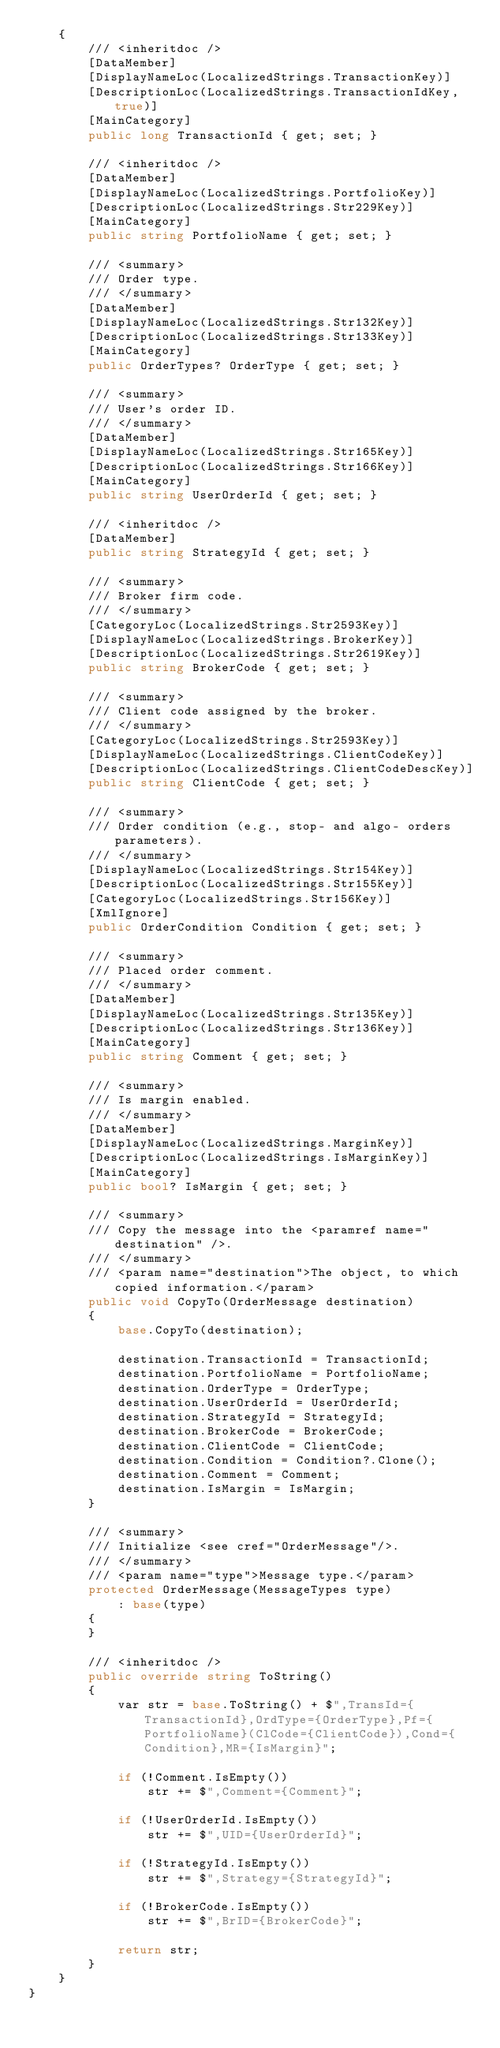<code> <loc_0><loc_0><loc_500><loc_500><_C#_>	{
		/// <inheritdoc />
		[DataMember]
		[DisplayNameLoc(LocalizedStrings.TransactionKey)]
		[DescriptionLoc(LocalizedStrings.TransactionIdKey, true)]
		[MainCategory]
		public long TransactionId { get; set; }

		/// <inheritdoc />
		[DataMember]
		[DisplayNameLoc(LocalizedStrings.PortfolioKey)]
		[DescriptionLoc(LocalizedStrings.Str229Key)]
		[MainCategory]
		public string PortfolioName { get; set; }

		/// <summary>
		/// Order type.
		/// </summary>
		[DataMember]
		[DisplayNameLoc(LocalizedStrings.Str132Key)]
		[DescriptionLoc(LocalizedStrings.Str133Key)]
		[MainCategory]
		public OrderTypes? OrderType { get; set; }

		/// <summary>
		/// User's order ID.
		/// </summary>
		[DataMember]
		[DisplayNameLoc(LocalizedStrings.Str165Key)]
		[DescriptionLoc(LocalizedStrings.Str166Key)]
		[MainCategory]
		public string UserOrderId { get; set; }

		/// <inheritdoc />
		[DataMember]
		public string StrategyId { get; set; }

		/// <summary>
		/// Broker firm code.
		/// </summary>
		[CategoryLoc(LocalizedStrings.Str2593Key)]
		[DisplayNameLoc(LocalizedStrings.BrokerKey)]
		[DescriptionLoc(LocalizedStrings.Str2619Key)]
		public string BrokerCode { get; set; }

		/// <summary>
		/// Client code assigned by the broker.
		/// </summary>
		[CategoryLoc(LocalizedStrings.Str2593Key)]
		[DisplayNameLoc(LocalizedStrings.ClientCodeKey)]
		[DescriptionLoc(LocalizedStrings.ClientCodeDescKey)]
		public string ClientCode { get; set; }

		/// <summary>
		/// Order condition (e.g., stop- and algo- orders parameters).
		/// </summary>
		[DisplayNameLoc(LocalizedStrings.Str154Key)]
		[DescriptionLoc(LocalizedStrings.Str155Key)]
		[CategoryLoc(LocalizedStrings.Str156Key)]
		[XmlIgnore]
		public OrderCondition Condition { get; set; }

		/// <summary>
		/// Placed order comment.
		/// </summary>
		[DataMember]
		[DisplayNameLoc(LocalizedStrings.Str135Key)]
		[DescriptionLoc(LocalizedStrings.Str136Key)]
		[MainCategory]
		public string Comment { get; set; }

		/// <summary>
		/// Is margin enabled.
		/// </summary>
		[DataMember]
		[DisplayNameLoc(LocalizedStrings.MarginKey)]
		[DescriptionLoc(LocalizedStrings.IsMarginKey)]
		[MainCategory]
		public bool? IsMargin { get; set; }

		/// <summary>
		/// Copy the message into the <paramref name="destination" />.
		/// </summary>
		/// <param name="destination">The object, to which copied information.</param>
		public void CopyTo(OrderMessage destination)
		{
			base.CopyTo(destination);

			destination.TransactionId = TransactionId;
			destination.PortfolioName = PortfolioName;
			destination.OrderType = OrderType;
			destination.UserOrderId = UserOrderId;
			destination.StrategyId = StrategyId;
			destination.BrokerCode = BrokerCode;
			destination.ClientCode = ClientCode;
			destination.Condition = Condition?.Clone();
			destination.Comment = Comment;
			destination.IsMargin = IsMargin;
		}

		/// <summary>
		/// Initialize <see cref="OrderMessage"/>.
		/// </summary>
		/// <param name="type">Message type.</param>
		protected OrderMessage(MessageTypes type)
			: base(type)
		{
		}

		/// <inheritdoc />
		public override string ToString()
		{
			var str = base.ToString() + $",TransId={TransactionId},OrdType={OrderType},Pf={PortfolioName}(ClCode={ClientCode}),Cond={Condition},MR={IsMargin}";

			if (!Comment.IsEmpty())
				str += $",Comment={Comment}";

			if (!UserOrderId.IsEmpty())
				str += $",UID={UserOrderId}";

			if (!StrategyId.IsEmpty())
				str += $",Strategy={StrategyId}";

			if (!BrokerCode.IsEmpty())
				str += $",BrID={BrokerCode}";

			return str;
		}
	}
}</code> 